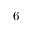Convert formula to latex. <formula><loc_0><loc_0><loc_500><loc_500>6</formula> 